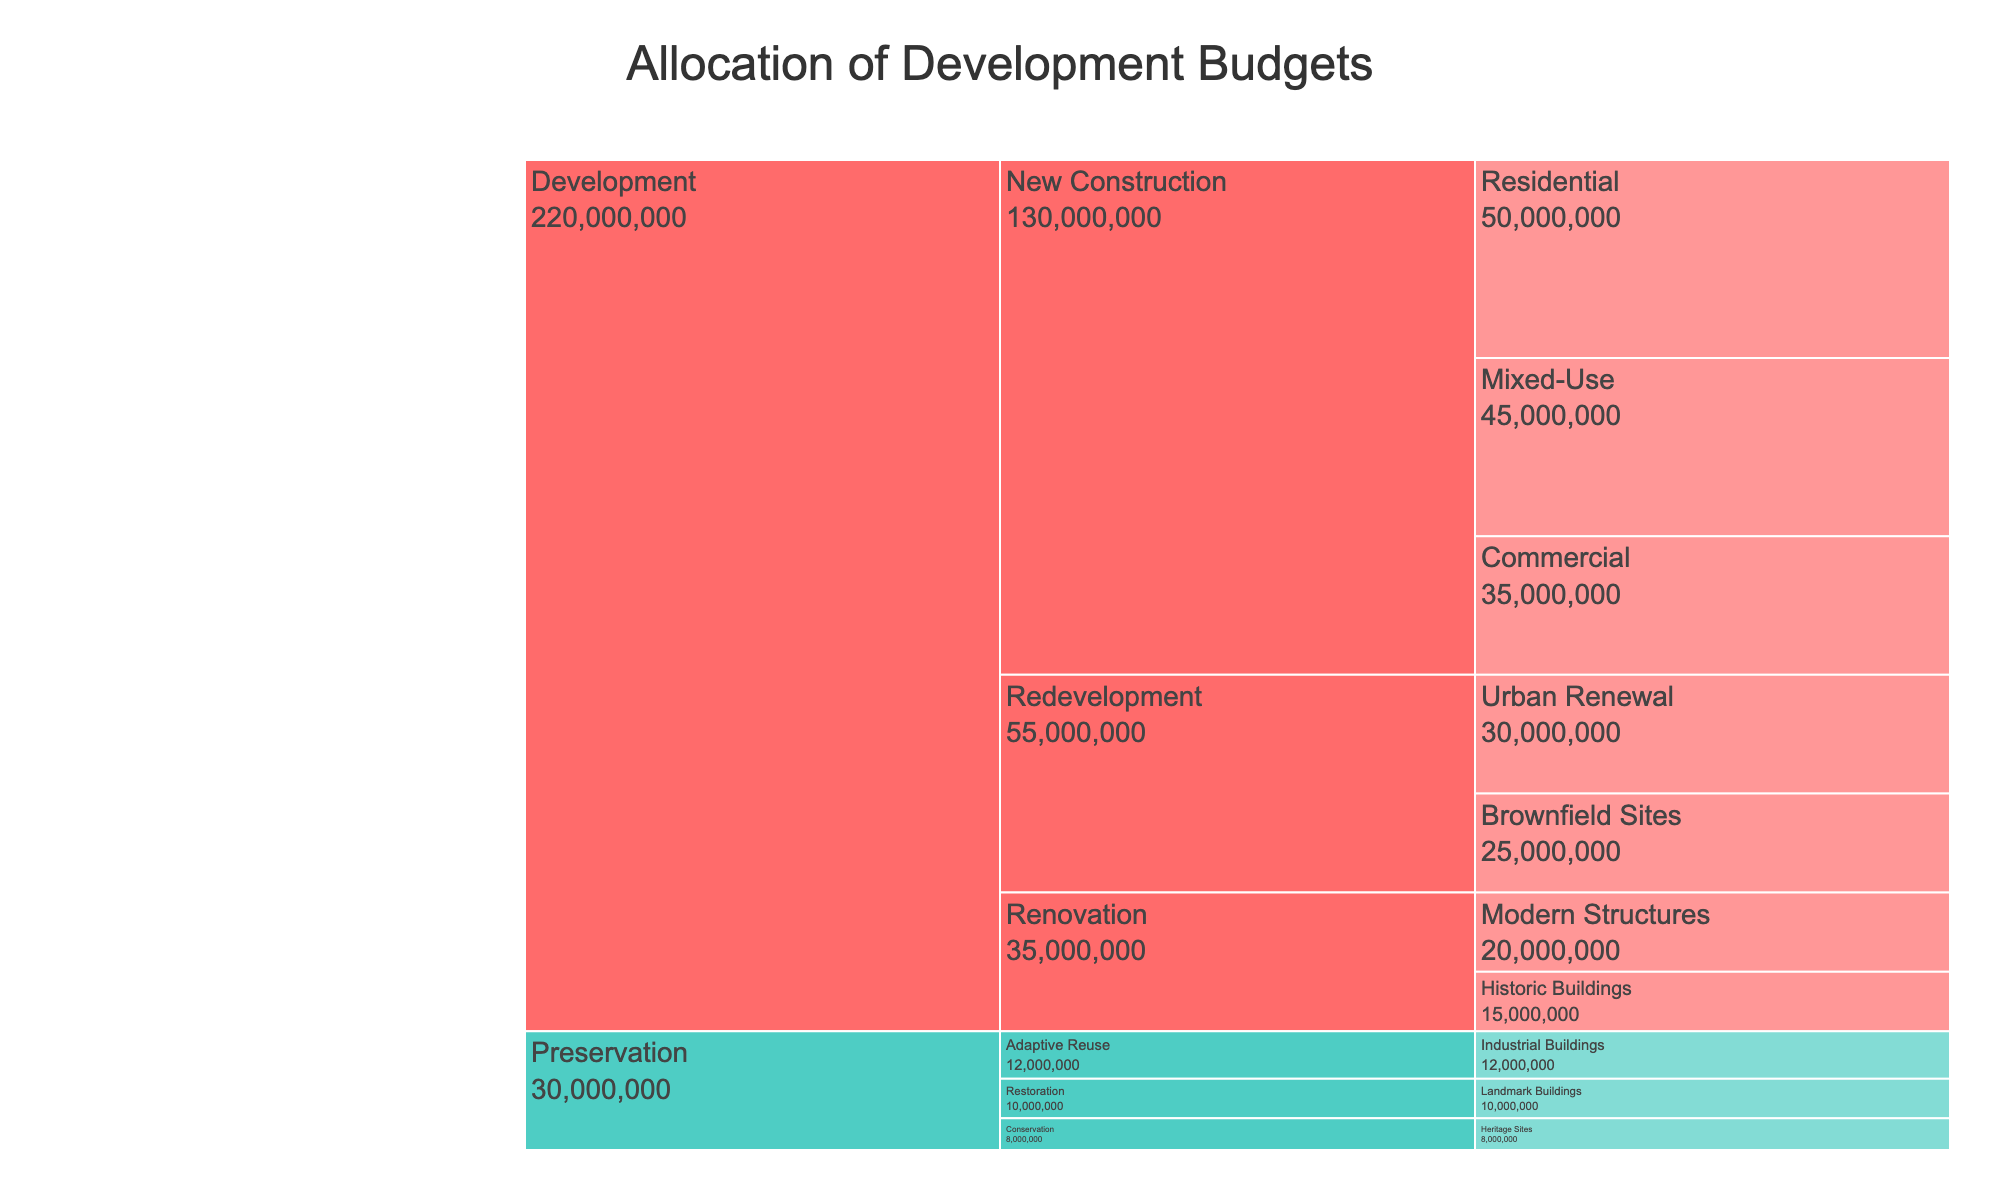what is the total budget allocated to 'Development' and 'Preservation' projects respectively? To find the total budget for 'Development' and 'Preservation', sum up the budgets of their subcategories: 'Development': 50M + 35M + 45M + 15M + 20M + 25M + 30M = 220M, 'Preservation': 10M + 8M + 12M = 30M
Answer: 'Development': 220M, 'Preservation': 30M which project type receives the highest budget: 'New Construction' or 'Redevelopment'? Sum the budgets for 'New Construction' categories: 50M + 35M + 45M = 130M. Sum the budgets for 'Redevelopment': 25M + 30M = 55M. Compare the two sums
Answer: 'New Construction' what is the largest budget allocated to a single subcategory? Review the budgets of all subcategories: Residential (50M), Commercial (35M), Mixed-Use (45M), Historic Buildings (15M), Modern Structures (20M), Brownfield Sites (25M), Urban Renewal (30M), Landmark Buildings (10M), Heritage Sites (8M), Industrial Buildings (12M). The largest is Residential with 50M
Answer: Residential Is there a larger budget allocated to 'Adaptive Reuse' than to 'Landmark Buildings'? The budget for 'Adaptive Reuse' (Industrial Buildings) is 12M and for 'Landmark Buildings' is 10M. Compare the two values
Answer: Yes, 12M vs 10M among 'New Construction' categories, which subcategory has the smallest budget? Review the 'New Construction' subcategory budgets: Residential (50M), Commercial (35M), Mixed-Use (45M). The smallest is for Commercial at 35M
Answer: Commercial what proportion of the total budget goes to 'Preservation'? First, calculate the total budget (220M for 'Development' + 30M for 'Preservation' = 250M). Then, the proportion for 'Preservation' is 30M / 250M = 0.12 or 12%
Answer: 12% how does the budget allocation to 'Urban Renewal' compare to 'Brownfield Sites'? Check the budgets: Urban Renewal is 30M, Brownfield Sites is 25M. Urban Renewal has 5M more
Answer: Urban Renewal has 5M more which category has more subcategories: 'Renovation' or 'Restoration'? Count the subcategories. 'Renovation' has Historic Buildings and Modern Structures (2); 'Restoration' only includes Landmark Buildings (1)
Answer: Renovation is the budget for 'Renovation' of Historic Buildings greater than that for 'Conservation' of Heritage Sites? Compare the budgets: Historic Buildings (15M) and Heritage Sites (8M). Historic Buildings has more budget
Answer: Yes, 15M vs 8M how does the budget for 'Modern Structures' compare to 'Commercial' in 'New Construction'? Compare their budgets: Modern Structures (20M) vs Commercial (35M). 35M is greater
Answer: Commercial has a larger budget 